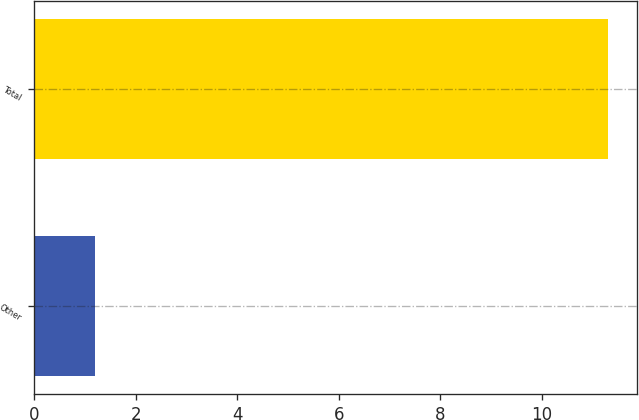Convert chart. <chart><loc_0><loc_0><loc_500><loc_500><bar_chart><fcel>Other<fcel>Total<nl><fcel>1.2<fcel>11.3<nl></chart> 